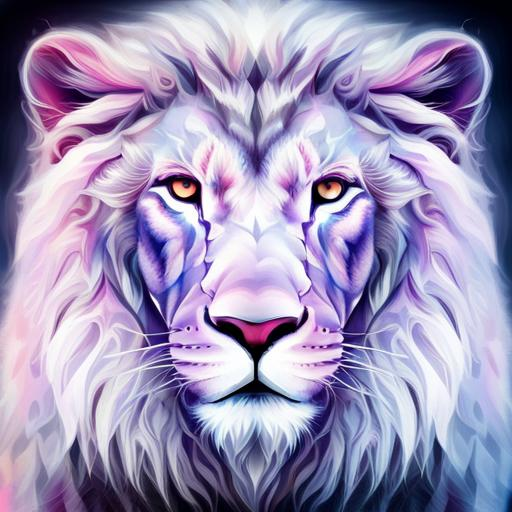What techniques might the artist have used to create this image? The artist may have utilized digital painting tools to create this image, employing techniques like layering, brushstroke variation, and color blending to achieve the vibrant and ethereal quality seen here. The use of gradient colors and soft transitions suggests proficiency in digital art software. 